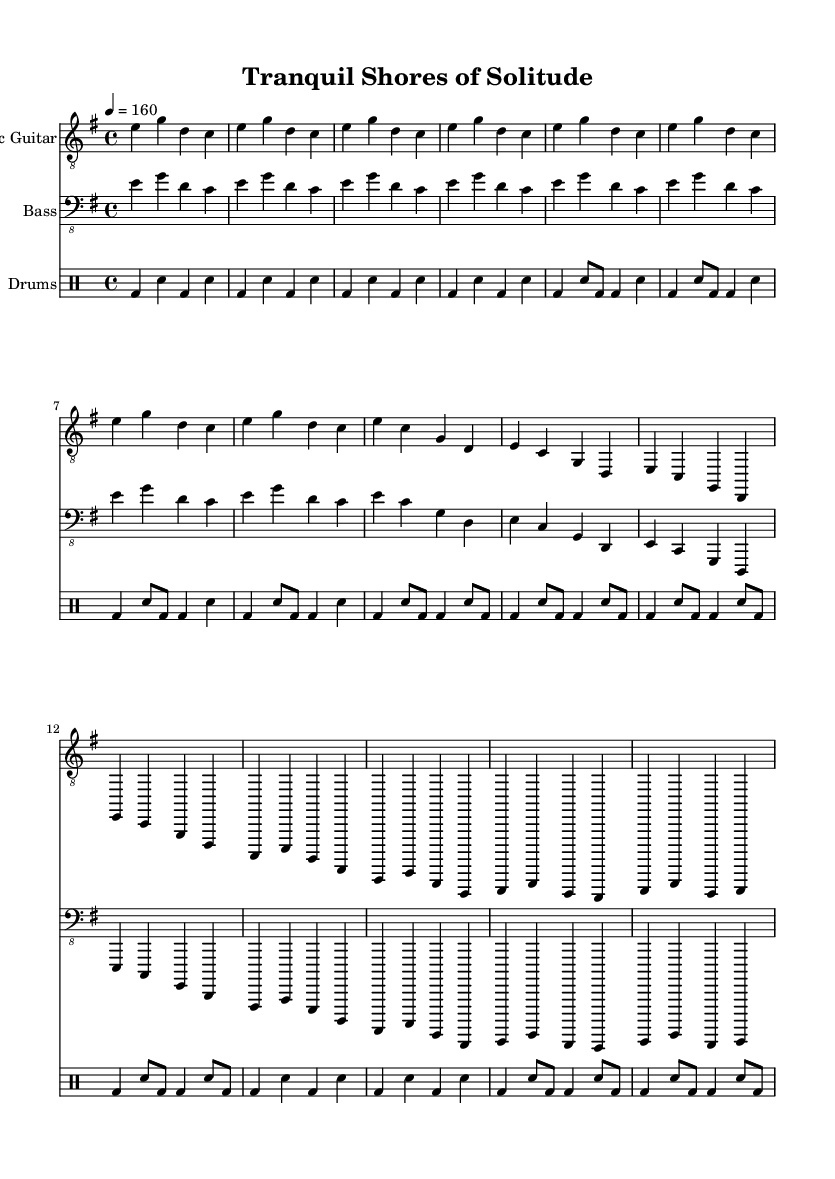What is the key signature of this music? The key signature is indicated by the number of sharps or flats in the part at the beginning of the sheet music. Here, it shows one sharp, which denotes E minor as indicated.
Answer: E minor What is the time signature of this music? The time signature appears at the beginning and consists of two numbers, where the top number indicates the number of beats in a measure and the bottom number indicates the note value that gets one beat. In this case, it shows 4/4, meaning there are four beats per measure.
Answer: 4/4 What is the tempo marking for this piece? The tempo marking appears next to the time signature and indicates how fast the piece should be played. Here, it shows “4 = 160”, meaning there are 160 beats per minute played.
Answer: 160 How many measures are there in the intro section? The intro section is presented in the first part of the sheet music where we can count the number of measures indicated by the vertical lines. Counting them will give the total. There are four measures.
Answer: 4 What is the primary chord used in the chorus? To determine the chords in the chorus, we look for the specific notes being played simultaneously during that section. The notes e, c, g, and d are played together, signifying the use of E minor chord primarily.
Answer: E minor What type of instrument plays the melody in this piece? The type of instrument used can often be identified by the staff notation and clefs shown. The melody is played on the treble clef, which is commonly associated with electric guitars in rock and metal music.
Answer: Electric guitar What rhythmic pattern does the drum part follow during the verse? Analyzing the drum part, each measure in the verse can be counted for note types and placements. The drum part here features a kick drum, snare, and hi-hat, creating a consistent driving rhythm typical in metal tracks.
Answer: Kick and snare 